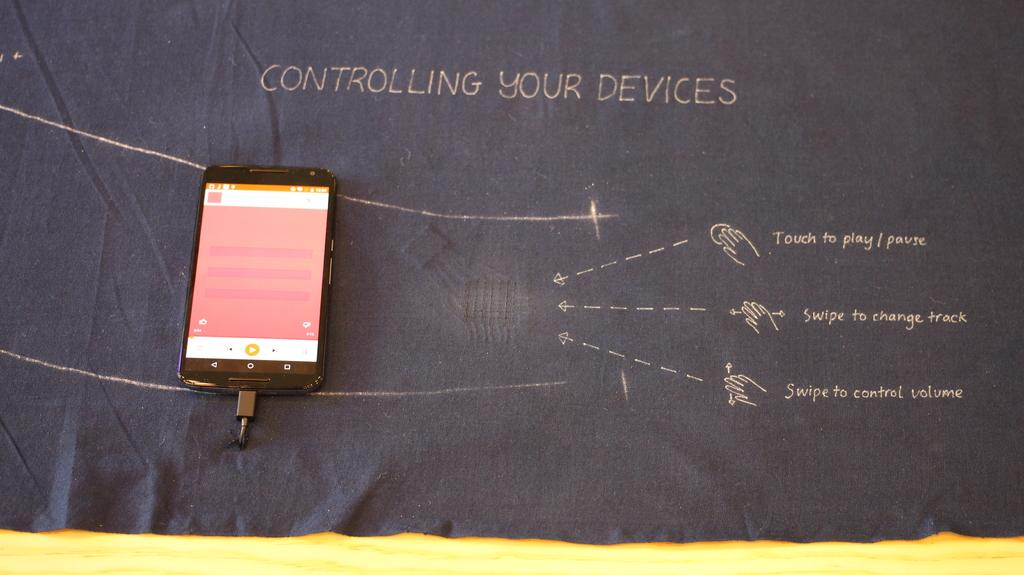Provide a one-sentence caption for the provided image. A phone sits on a piece of fabric with the words Controlling Your Devices written at the top. 